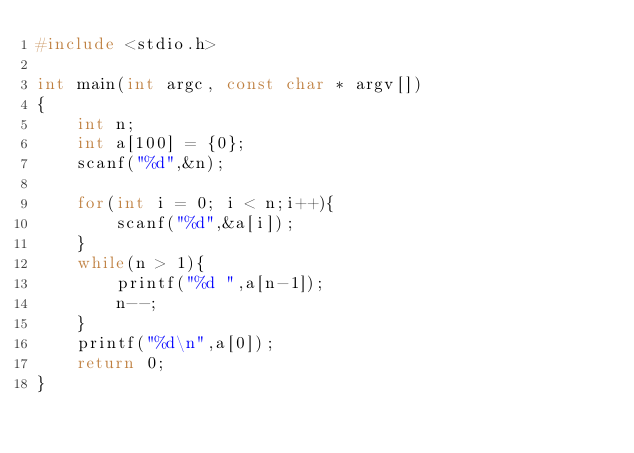<code> <loc_0><loc_0><loc_500><loc_500><_C_>#include <stdio.h>

int main(int argc, const char * argv[])
{
    int n;
    int a[100] = {0};
    scanf("%d",&n);
    
    for(int i = 0; i < n;i++){
        scanf("%d",&a[i]);
    }
    while(n > 1){
        printf("%d ",a[n-1]);
        n--;
    }
    printf("%d\n",a[0]);
    return 0;
}</code> 